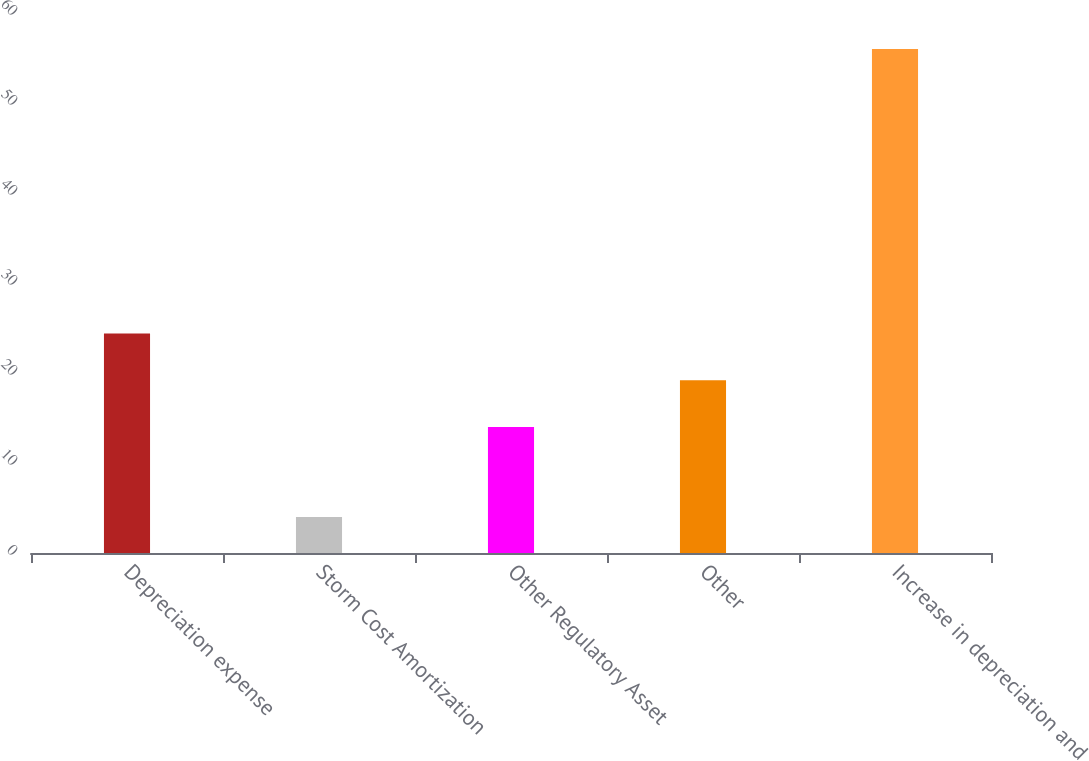Convert chart. <chart><loc_0><loc_0><loc_500><loc_500><bar_chart><fcel>Depreciation expense<fcel>Storm Cost Amortization<fcel>Other Regulatory Asset<fcel>Other<fcel>Increase in depreciation and<nl><fcel>24.4<fcel>4<fcel>14<fcel>19.2<fcel>56<nl></chart> 